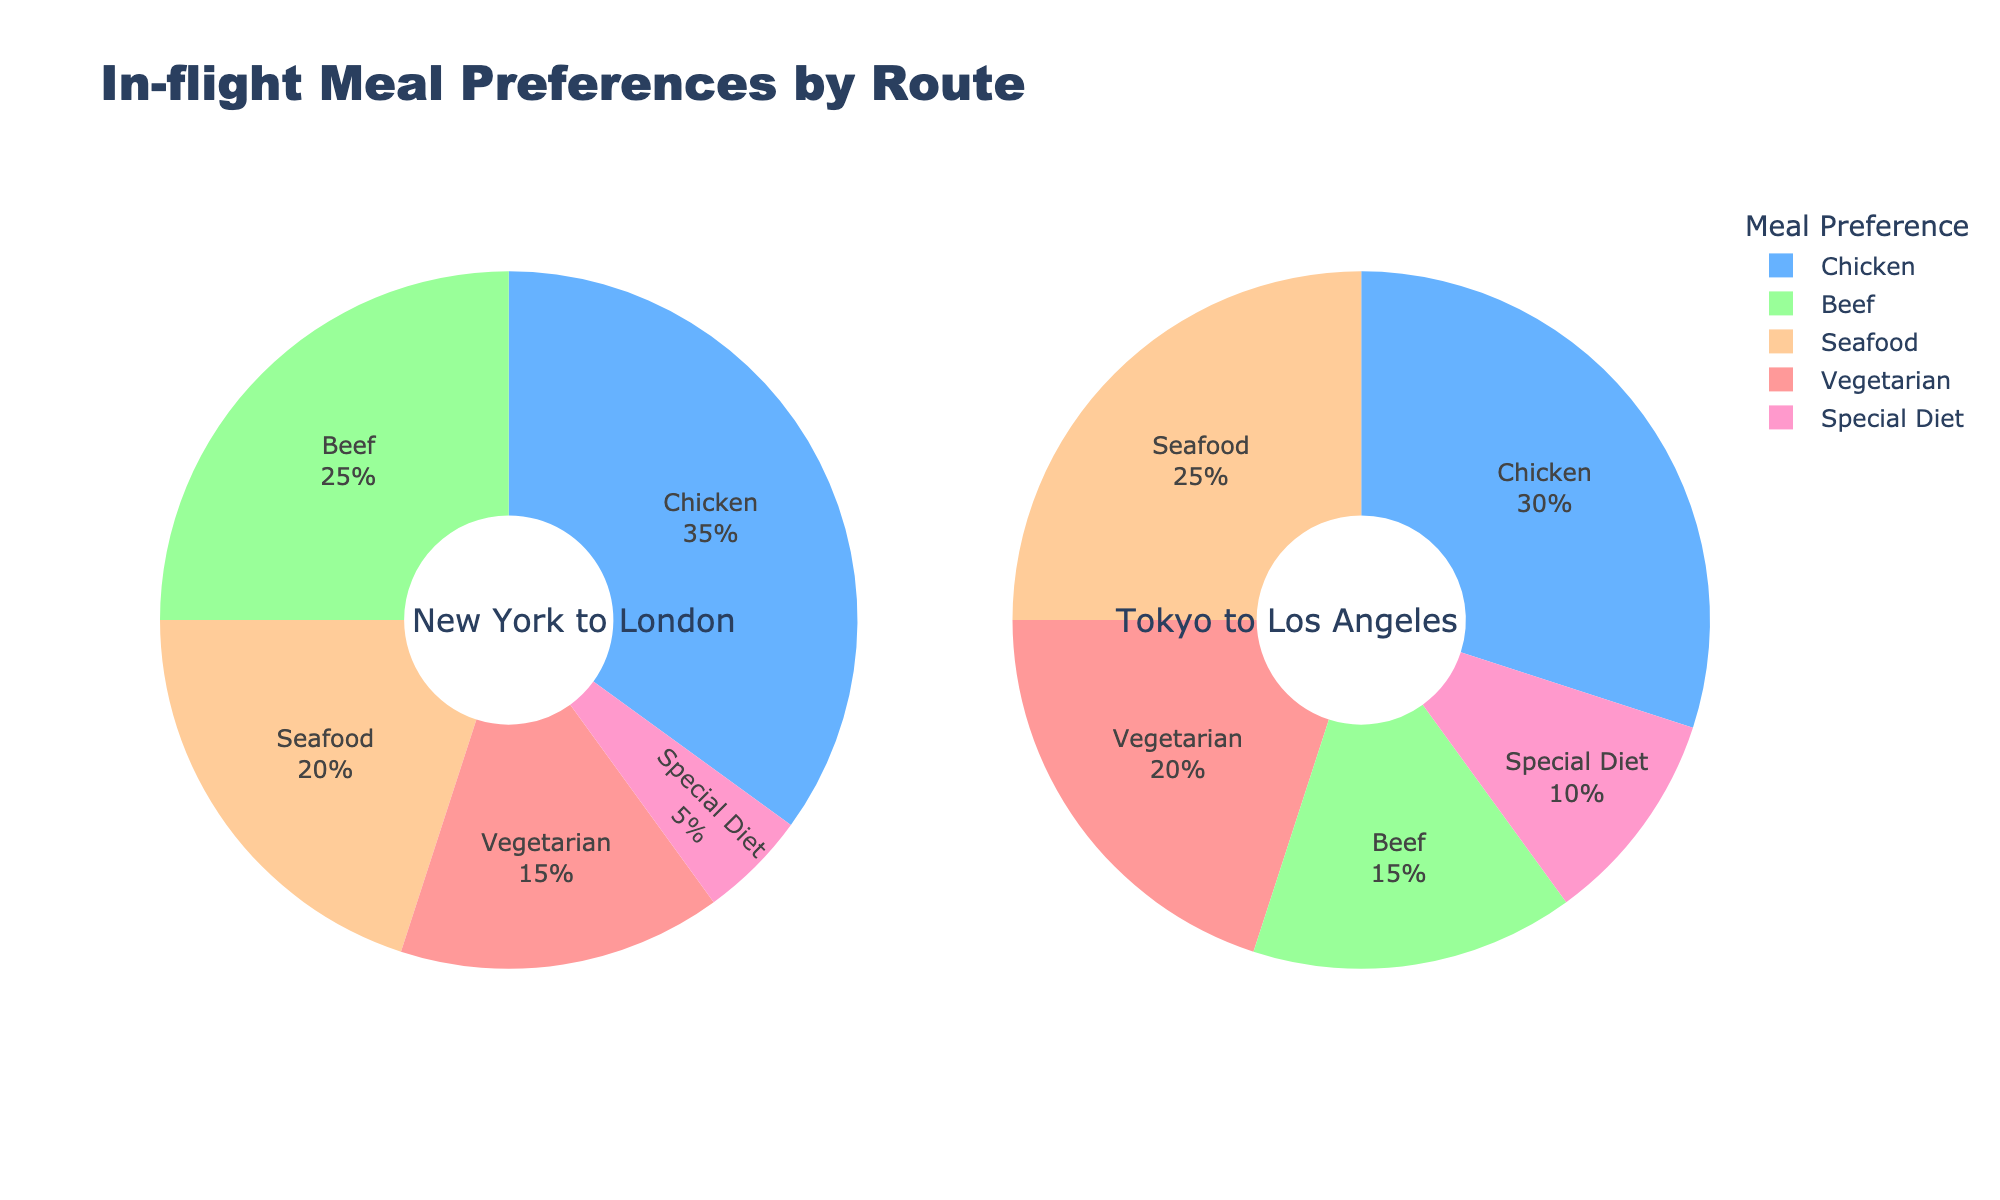Which meal preference has the highest percentage on the New York to London route? Look at the pie chart for New York to London route. The segment with the largest size is 'Chicken'.
Answer: Chicken Which meal preference has the lowest percentage on the Tokyo to Los Angeles route? Refer to the pie chart for Tokyo to Los Angeles route. The smallest segment is marked 'Special Diet'.
Answer: Special Diet Compare the percentage of vegetarian meal preferences between New York to London and Tokyo to Los Angeles routes. Which route has a higher percentage? Observe the vegetarian meal percentages on both routes' pie charts. New York to London has 15%, while Tokyo to Los Angeles has 20%. Therefore, Tokyo to Los Angeles has a higher percentage.
Answer: Tokyo to Los Angeles What is the total percentage of passengers who preferred Beef and Seafood combined on the New York to London route? Sum the percentages of Beef and Seafood preferences on the New York to London route: 25% (Beef) + 20% (Seafood) = 45%.
Answer: 45% Which route has a greater proportion of seafood meal preferences: New York to London or Tokyo to Los Angeles? Compare the seafood meal preference percentages of both routes. New York to London is 20%, while Tokyo to Los Angeles is 25%. Thus, Tokyo to Los Angeles has a higher proportion.
Answer: Tokyo to Los Angeles If you combine Chicken and Beef preferences, which route has a higher combined percentage: New York to London or Tokyo to Los Angeles? Add the percentages for Chicken and Beef for both routes. For New York to London: 35% (Chicken) + 25% (Beef) = 60%. For Tokyo to Los Angeles: 30% (Chicken) + 15% (Beef) = 45%. So, New York to London has a higher combined percentage.
Answer: New York to London What is the difference in percentage between the highest and lowest meal preferences on the Tokyo to Los Angeles route? Identify the highest (Chicken at 30%) and the lowest (Special Diet at 10%) meal preferences. Subtract the lowest from the highest: 30% - 10% = 20%.
Answer: 20% Are there any meal preferences that have the same percentage on the routes shown in the pie charts? Look for segments with the same size percentage labels. Both New York to London and Tokyo to Los Angeles have "Special Diet" at 5%.
Answer: Yes What colors represent the Vegetarian and Seafood preferences on the chart? Identify the color for 'Vegetarian' and 'Seafood' segments on the pie charts. 'Vegetarian' is represented by red, and 'Seafood' is represented by yellow.
Answer: Red and Yellow Determine the ratio of passengers preferring Vegetarian meals to those preferring Chicken meals on the New York to London route. Identify the percentages of Vegetarian (15%) and Chicken (35%) preferences on this route. Divide the percentages: 15/35 = 3/7.
Answer: 3:7 